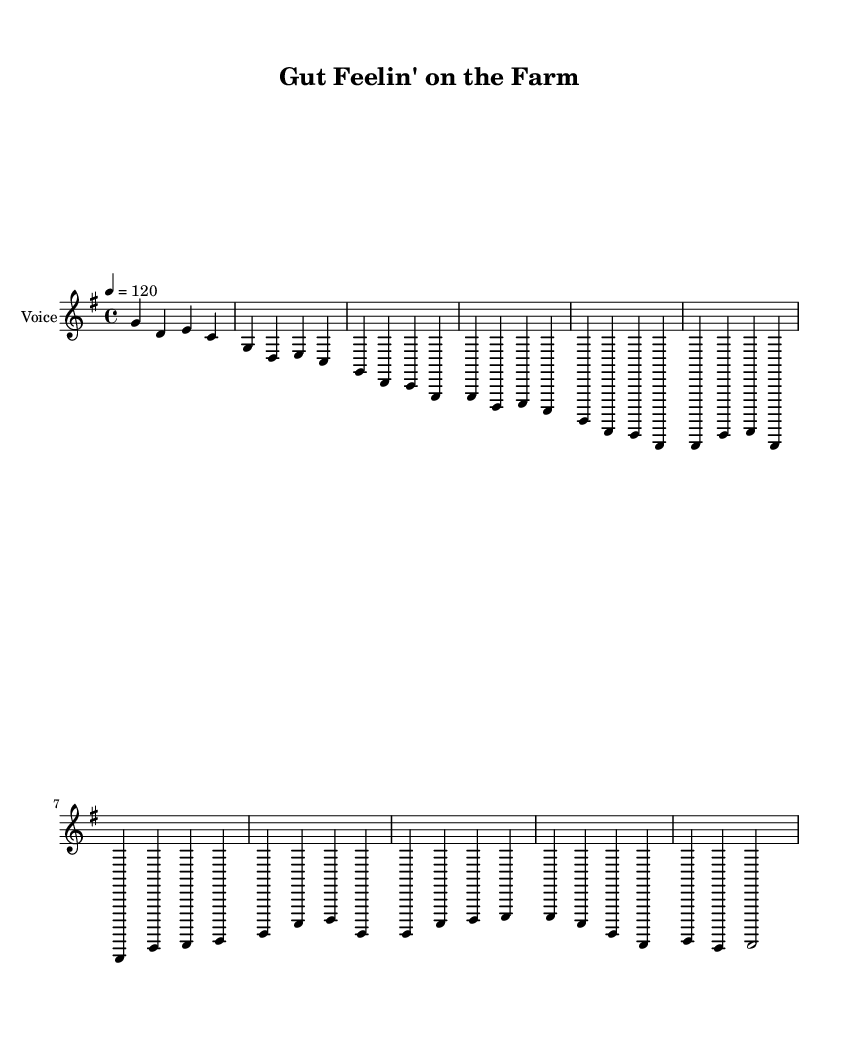What is the key signature of this music? The key signature is G major, which has one sharp (F#). This can be determined by observing the key signature indicated at the beginning of the staff.
Answer: G major What is the time signature of this piece? The time signature is 4/4, which means there are four beats in a measure and the quarter note gets one beat. This can be identified from the notation indicating the time signature right after the key signature.
Answer: 4/4 What is the tempo marking for this song? The tempo marking indicates a speed of 120 beats per minute. This is shown at the beginning of the sheet music below the title.
Answer: 120 How many measures are in the chorus section? The chorus is made up of four measures, which can be counted from the notation that shows the melody and the corresponding lyrics. Each section in the music is visually separated by vertical lines (bar lines), making it easy to count.
Answer: 4 What is the primary theme of the lyrics in verse one? The primary theme in verse one speaks of the rural setting and the benefits of fermented foods, as underscored by the lyrics about the farm and the strength of bellies. This can be interpreted from the text of the lyrics provided in the melody section.
Answer: Rural living and gut health What is the ending note of the bridge? The last note of the bridge section is D, which can be determined by looking at the last note in the melody for the bridge.
Answer: D 